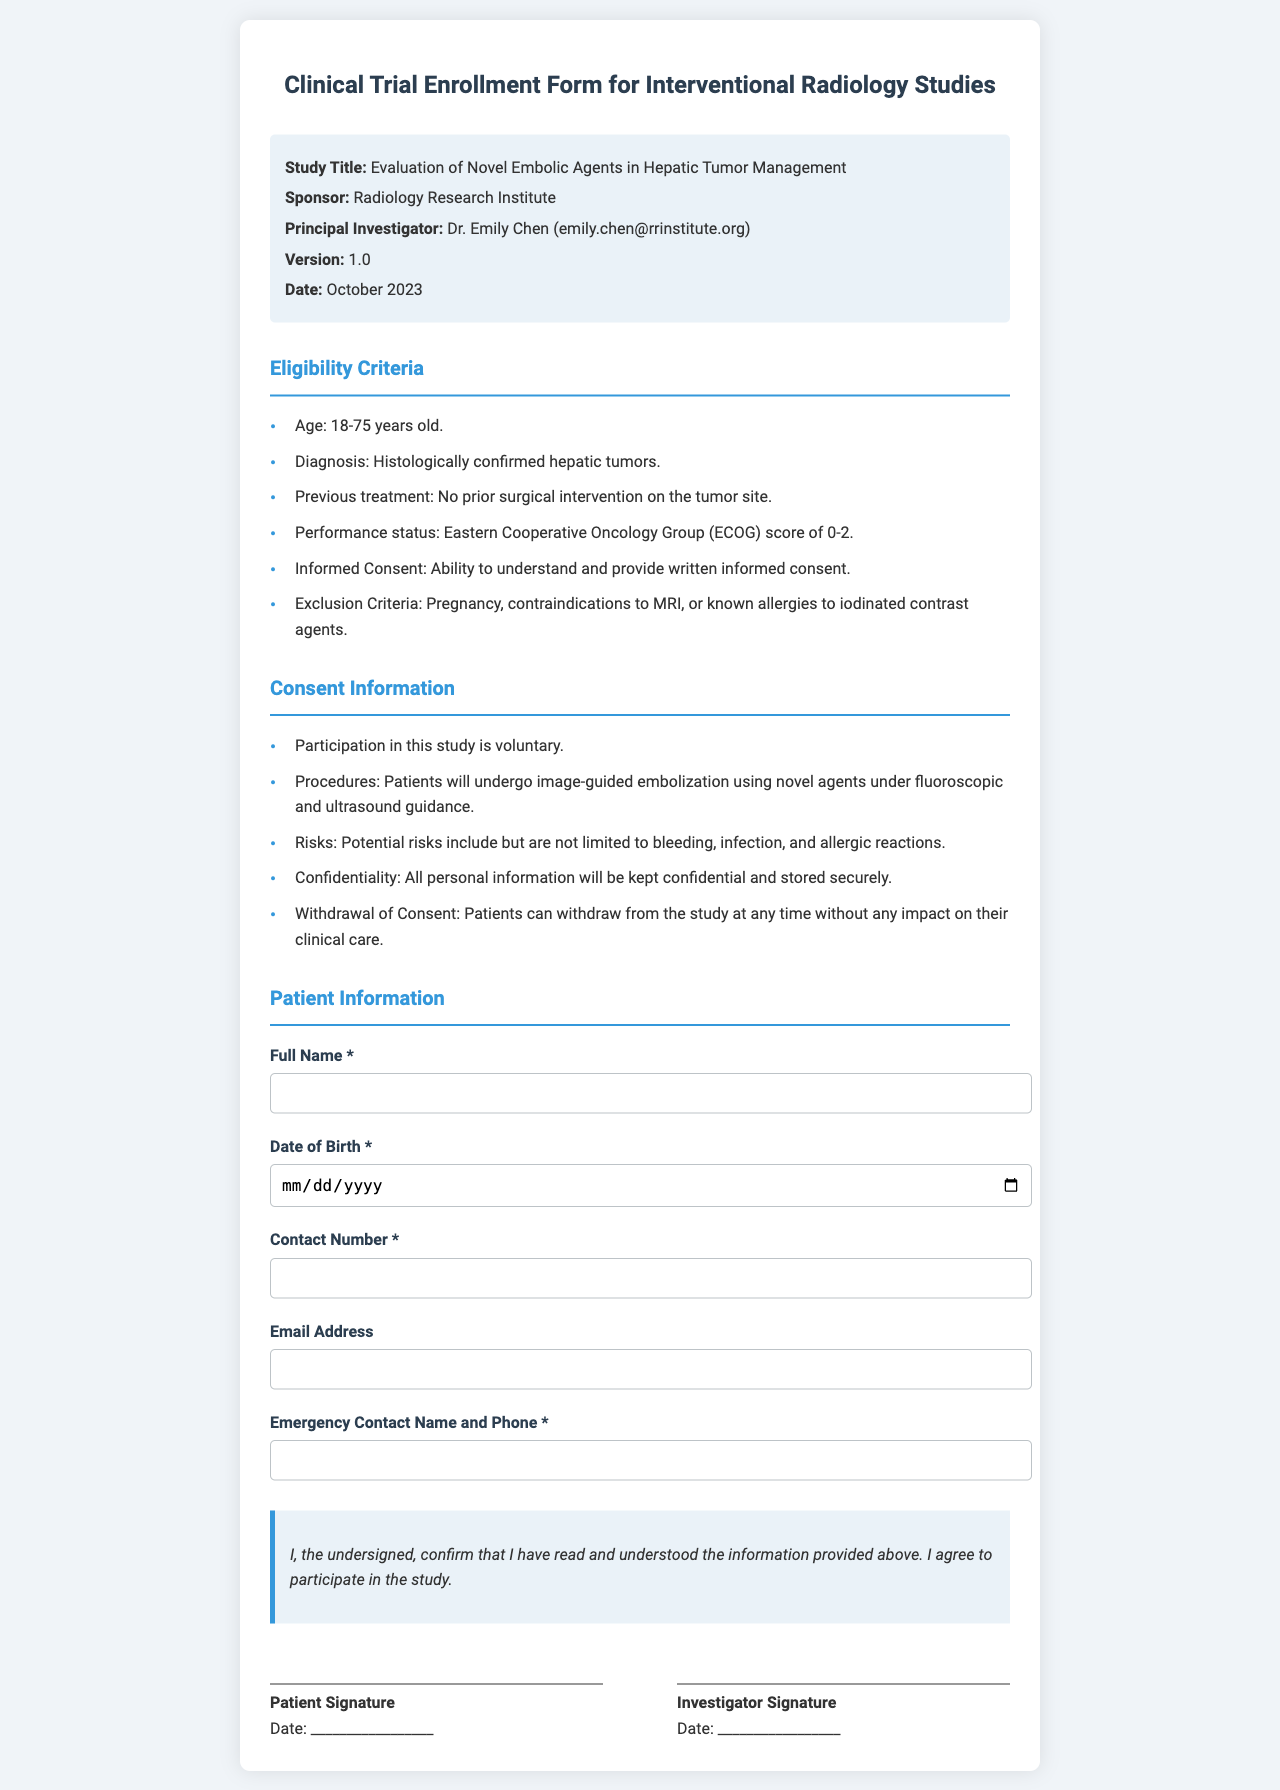What is the study title? The study title is specified in the document under the study information section.
Answer: Evaluation of Novel Embolic Agents in Hepatic Tumor Management Who is the principal investigator? The principal investigator's name is listed in the study information section.
Answer: Dr. Emily Chen What is the eligibility age range for participants? The eligibility criteria specify an age range for participants in the study.
Answer: 18-75 years old What are the exclusion criteria mentioned? The document lists specific factors that disqualify potential participants.
Answer: Pregnancy, contraindications to MRI, or known allergies to iodinated contrast agents What are the potential risks involved in the study? The consent information section provides details on the risks associated with the procedures.
Answer: Bleeding, infection, and allergic reactions What does the acknowledgment statement confirm? The acknowledgment section indicates what the patient agrees to regarding participation in the study.
Answer: I have read and understood the information provided above When was the document version issued? The date of the document version is indicated in the study information section.
Answer: October 2023 What is the contact method for Dr. Emily Chen? The contact information for the principal investigator is provided in the document.
Answer: emily.chen@rrinstitute.org 